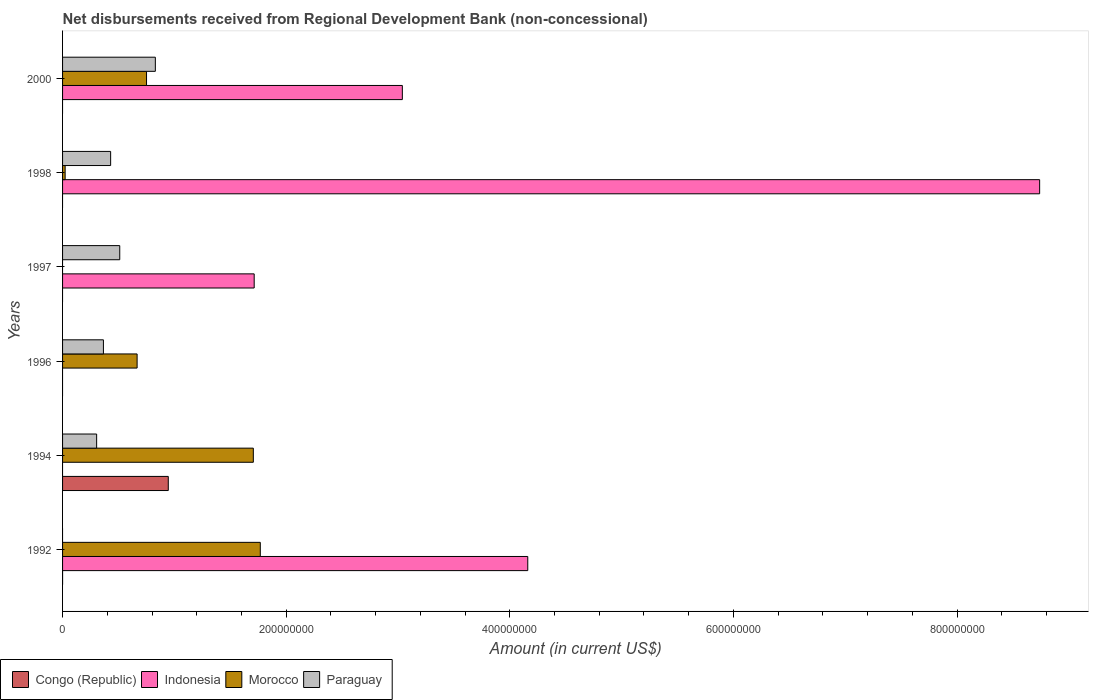Are the number of bars on each tick of the Y-axis equal?
Provide a succinct answer. No. How many bars are there on the 1st tick from the bottom?
Keep it short and to the point. 2. What is the label of the 1st group of bars from the top?
Keep it short and to the point. 2000. What is the amount of disbursements received from Regional Development Bank in Congo (Republic) in 2000?
Keep it short and to the point. 0. Across all years, what is the maximum amount of disbursements received from Regional Development Bank in Congo (Republic)?
Provide a succinct answer. 9.46e+07. What is the total amount of disbursements received from Regional Development Bank in Morocco in the graph?
Make the answer very short. 4.92e+08. What is the difference between the amount of disbursements received from Regional Development Bank in Indonesia in 1997 and that in 1998?
Your response must be concise. -7.03e+08. What is the difference between the amount of disbursements received from Regional Development Bank in Congo (Republic) in 1996 and the amount of disbursements received from Regional Development Bank in Paraguay in 2000?
Your answer should be very brief. -8.30e+07. What is the average amount of disbursements received from Regional Development Bank in Morocco per year?
Keep it short and to the point. 8.19e+07. In the year 1998, what is the difference between the amount of disbursements received from Regional Development Bank in Paraguay and amount of disbursements received from Regional Development Bank in Morocco?
Offer a very short reply. 4.07e+07. What is the ratio of the amount of disbursements received from Regional Development Bank in Morocco in 1992 to that in 1994?
Offer a terse response. 1.04. Is the amount of disbursements received from Regional Development Bank in Morocco in 1994 less than that in 1996?
Your answer should be very brief. No. What is the difference between the highest and the second highest amount of disbursements received from Regional Development Bank in Paraguay?
Keep it short and to the point. 3.18e+07. What is the difference between the highest and the lowest amount of disbursements received from Regional Development Bank in Paraguay?
Your answer should be compact. 8.30e+07. In how many years, is the amount of disbursements received from Regional Development Bank in Morocco greater than the average amount of disbursements received from Regional Development Bank in Morocco taken over all years?
Offer a terse response. 2. Is it the case that in every year, the sum of the amount of disbursements received from Regional Development Bank in Morocco and amount of disbursements received from Regional Development Bank in Congo (Republic) is greater than the sum of amount of disbursements received from Regional Development Bank in Indonesia and amount of disbursements received from Regional Development Bank in Paraguay?
Provide a short and direct response. No. How many bars are there?
Your answer should be compact. 15. Are all the bars in the graph horizontal?
Give a very brief answer. Yes. Are the values on the major ticks of X-axis written in scientific E-notation?
Provide a succinct answer. No. Does the graph contain any zero values?
Your answer should be compact. Yes. Does the graph contain grids?
Offer a terse response. No. Where does the legend appear in the graph?
Ensure brevity in your answer.  Bottom left. What is the title of the graph?
Make the answer very short. Net disbursements received from Regional Development Bank (non-concessional). Does "Kuwait" appear as one of the legend labels in the graph?
Keep it short and to the point. No. What is the label or title of the Y-axis?
Your response must be concise. Years. What is the Amount (in current US$) of Congo (Republic) in 1992?
Provide a succinct answer. 0. What is the Amount (in current US$) in Indonesia in 1992?
Keep it short and to the point. 4.16e+08. What is the Amount (in current US$) of Morocco in 1992?
Offer a very short reply. 1.77e+08. What is the Amount (in current US$) of Congo (Republic) in 1994?
Provide a succinct answer. 9.46e+07. What is the Amount (in current US$) of Indonesia in 1994?
Provide a short and direct response. 0. What is the Amount (in current US$) in Morocco in 1994?
Your answer should be compact. 1.71e+08. What is the Amount (in current US$) in Paraguay in 1994?
Ensure brevity in your answer.  3.05e+07. What is the Amount (in current US$) of Morocco in 1996?
Give a very brief answer. 6.67e+07. What is the Amount (in current US$) of Paraguay in 1996?
Provide a succinct answer. 3.65e+07. What is the Amount (in current US$) in Congo (Republic) in 1997?
Provide a short and direct response. 0. What is the Amount (in current US$) of Indonesia in 1997?
Make the answer very short. 1.71e+08. What is the Amount (in current US$) of Morocco in 1997?
Provide a short and direct response. 0. What is the Amount (in current US$) of Paraguay in 1997?
Your response must be concise. 5.11e+07. What is the Amount (in current US$) in Indonesia in 1998?
Your answer should be very brief. 8.74e+08. What is the Amount (in current US$) in Morocco in 1998?
Your response must be concise. 2.30e+06. What is the Amount (in current US$) in Paraguay in 1998?
Provide a succinct answer. 4.30e+07. What is the Amount (in current US$) of Congo (Republic) in 2000?
Provide a succinct answer. 0. What is the Amount (in current US$) of Indonesia in 2000?
Provide a short and direct response. 3.04e+08. What is the Amount (in current US$) in Morocco in 2000?
Give a very brief answer. 7.51e+07. What is the Amount (in current US$) of Paraguay in 2000?
Provide a short and direct response. 8.30e+07. Across all years, what is the maximum Amount (in current US$) in Congo (Republic)?
Offer a very short reply. 9.46e+07. Across all years, what is the maximum Amount (in current US$) in Indonesia?
Your response must be concise. 8.74e+08. Across all years, what is the maximum Amount (in current US$) of Morocco?
Your response must be concise. 1.77e+08. Across all years, what is the maximum Amount (in current US$) of Paraguay?
Provide a short and direct response. 8.30e+07. Across all years, what is the minimum Amount (in current US$) in Indonesia?
Your response must be concise. 0. Across all years, what is the minimum Amount (in current US$) in Paraguay?
Provide a short and direct response. 0. What is the total Amount (in current US$) in Congo (Republic) in the graph?
Give a very brief answer. 9.46e+07. What is the total Amount (in current US$) in Indonesia in the graph?
Provide a succinct answer. 1.77e+09. What is the total Amount (in current US$) in Morocco in the graph?
Provide a short and direct response. 4.92e+08. What is the total Amount (in current US$) in Paraguay in the graph?
Your answer should be very brief. 2.44e+08. What is the difference between the Amount (in current US$) in Morocco in 1992 and that in 1994?
Give a very brief answer. 6.23e+06. What is the difference between the Amount (in current US$) in Morocco in 1992 and that in 1996?
Provide a short and direct response. 1.10e+08. What is the difference between the Amount (in current US$) in Indonesia in 1992 and that in 1997?
Your answer should be compact. 2.45e+08. What is the difference between the Amount (in current US$) of Indonesia in 1992 and that in 1998?
Make the answer very short. -4.58e+08. What is the difference between the Amount (in current US$) of Morocco in 1992 and that in 1998?
Provide a succinct answer. 1.75e+08. What is the difference between the Amount (in current US$) in Indonesia in 1992 and that in 2000?
Provide a short and direct response. 1.12e+08. What is the difference between the Amount (in current US$) of Morocco in 1992 and that in 2000?
Your answer should be compact. 1.02e+08. What is the difference between the Amount (in current US$) in Morocco in 1994 and that in 1996?
Ensure brevity in your answer.  1.04e+08. What is the difference between the Amount (in current US$) in Paraguay in 1994 and that in 1996?
Your answer should be compact. -6.06e+06. What is the difference between the Amount (in current US$) in Paraguay in 1994 and that in 1997?
Keep it short and to the point. -2.07e+07. What is the difference between the Amount (in current US$) of Morocco in 1994 and that in 1998?
Offer a very short reply. 1.68e+08. What is the difference between the Amount (in current US$) in Paraguay in 1994 and that in 1998?
Make the answer very short. -1.25e+07. What is the difference between the Amount (in current US$) of Morocco in 1994 and that in 2000?
Keep it short and to the point. 9.55e+07. What is the difference between the Amount (in current US$) in Paraguay in 1994 and that in 2000?
Offer a terse response. -5.25e+07. What is the difference between the Amount (in current US$) of Paraguay in 1996 and that in 1997?
Your answer should be compact. -1.46e+07. What is the difference between the Amount (in current US$) of Morocco in 1996 and that in 1998?
Your response must be concise. 6.44e+07. What is the difference between the Amount (in current US$) of Paraguay in 1996 and that in 1998?
Make the answer very short. -6.46e+06. What is the difference between the Amount (in current US$) in Morocco in 1996 and that in 2000?
Keep it short and to the point. -8.43e+06. What is the difference between the Amount (in current US$) of Paraguay in 1996 and that in 2000?
Ensure brevity in your answer.  -4.64e+07. What is the difference between the Amount (in current US$) of Indonesia in 1997 and that in 1998?
Your answer should be very brief. -7.03e+08. What is the difference between the Amount (in current US$) in Paraguay in 1997 and that in 1998?
Offer a very short reply. 8.14e+06. What is the difference between the Amount (in current US$) in Indonesia in 1997 and that in 2000?
Ensure brevity in your answer.  -1.33e+08. What is the difference between the Amount (in current US$) of Paraguay in 1997 and that in 2000?
Give a very brief answer. -3.18e+07. What is the difference between the Amount (in current US$) in Indonesia in 1998 and that in 2000?
Provide a short and direct response. 5.70e+08. What is the difference between the Amount (in current US$) in Morocco in 1998 and that in 2000?
Offer a very short reply. -7.28e+07. What is the difference between the Amount (in current US$) in Paraguay in 1998 and that in 2000?
Give a very brief answer. -4.00e+07. What is the difference between the Amount (in current US$) in Indonesia in 1992 and the Amount (in current US$) in Morocco in 1994?
Provide a succinct answer. 2.45e+08. What is the difference between the Amount (in current US$) in Indonesia in 1992 and the Amount (in current US$) in Paraguay in 1994?
Provide a short and direct response. 3.86e+08. What is the difference between the Amount (in current US$) of Morocco in 1992 and the Amount (in current US$) of Paraguay in 1994?
Offer a very short reply. 1.46e+08. What is the difference between the Amount (in current US$) in Indonesia in 1992 and the Amount (in current US$) in Morocco in 1996?
Offer a very short reply. 3.49e+08. What is the difference between the Amount (in current US$) in Indonesia in 1992 and the Amount (in current US$) in Paraguay in 1996?
Your response must be concise. 3.80e+08. What is the difference between the Amount (in current US$) of Morocco in 1992 and the Amount (in current US$) of Paraguay in 1996?
Provide a short and direct response. 1.40e+08. What is the difference between the Amount (in current US$) of Indonesia in 1992 and the Amount (in current US$) of Paraguay in 1997?
Provide a succinct answer. 3.65e+08. What is the difference between the Amount (in current US$) of Morocco in 1992 and the Amount (in current US$) of Paraguay in 1997?
Provide a short and direct response. 1.26e+08. What is the difference between the Amount (in current US$) of Indonesia in 1992 and the Amount (in current US$) of Morocco in 1998?
Your response must be concise. 4.14e+08. What is the difference between the Amount (in current US$) of Indonesia in 1992 and the Amount (in current US$) of Paraguay in 1998?
Provide a short and direct response. 3.73e+08. What is the difference between the Amount (in current US$) in Morocco in 1992 and the Amount (in current US$) in Paraguay in 1998?
Offer a terse response. 1.34e+08. What is the difference between the Amount (in current US$) in Indonesia in 1992 and the Amount (in current US$) in Morocco in 2000?
Make the answer very short. 3.41e+08. What is the difference between the Amount (in current US$) of Indonesia in 1992 and the Amount (in current US$) of Paraguay in 2000?
Your response must be concise. 3.33e+08. What is the difference between the Amount (in current US$) in Morocco in 1992 and the Amount (in current US$) in Paraguay in 2000?
Your response must be concise. 9.39e+07. What is the difference between the Amount (in current US$) of Congo (Republic) in 1994 and the Amount (in current US$) of Morocco in 1996?
Your answer should be very brief. 2.79e+07. What is the difference between the Amount (in current US$) of Congo (Republic) in 1994 and the Amount (in current US$) of Paraguay in 1996?
Ensure brevity in your answer.  5.80e+07. What is the difference between the Amount (in current US$) of Morocco in 1994 and the Amount (in current US$) of Paraguay in 1996?
Provide a succinct answer. 1.34e+08. What is the difference between the Amount (in current US$) of Congo (Republic) in 1994 and the Amount (in current US$) of Indonesia in 1997?
Provide a succinct answer. -7.68e+07. What is the difference between the Amount (in current US$) in Congo (Republic) in 1994 and the Amount (in current US$) in Paraguay in 1997?
Make the answer very short. 4.34e+07. What is the difference between the Amount (in current US$) of Morocco in 1994 and the Amount (in current US$) of Paraguay in 1997?
Give a very brief answer. 1.19e+08. What is the difference between the Amount (in current US$) of Congo (Republic) in 1994 and the Amount (in current US$) of Indonesia in 1998?
Keep it short and to the point. -7.79e+08. What is the difference between the Amount (in current US$) in Congo (Republic) in 1994 and the Amount (in current US$) in Morocco in 1998?
Make the answer very short. 9.23e+07. What is the difference between the Amount (in current US$) of Congo (Republic) in 1994 and the Amount (in current US$) of Paraguay in 1998?
Make the answer very short. 5.16e+07. What is the difference between the Amount (in current US$) in Morocco in 1994 and the Amount (in current US$) in Paraguay in 1998?
Offer a very short reply. 1.28e+08. What is the difference between the Amount (in current US$) of Congo (Republic) in 1994 and the Amount (in current US$) of Indonesia in 2000?
Give a very brief answer. -2.09e+08. What is the difference between the Amount (in current US$) of Congo (Republic) in 1994 and the Amount (in current US$) of Morocco in 2000?
Offer a very short reply. 1.95e+07. What is the difference between the Amount (in current US$) in Congo (Republic) in 1994 and the Amount (in current US$) in Paraguay in 2000?
Offer a terse response. 1.16e+07. What is the difference between the Amount (in current US$) in Morocco in 1994 and the Amount (in current US$) in Paraguay in 2000?
Your response must be concise. 8.76e+07. What is the difference between the Amount (in current US$) of Morocco in 1996 and the Amount (in current US$) of Paraguay in 1997?
Ensure brevity in your answer.  1.55e+07. What is the difference between the Amount (in current US$) of Morocco in 1996 and the Amount (in current US$) of Paraguay in 1998?
Offer a terse response. 2.37e+07. What is the difference between the Amount (in current US$) in Morocco in 1996 and the Amount (in current US$) in Paraguay in 2000?
Make the answer very short. -1.63e+07. What is the difference between the Amount (in current US$) in Indonesia in 1997 and the Amount (in current US$) in Morocco in 1998?
Provide a short and direct response. 1.69e+08. What is the difference between the Amount (in current US$) of Indonesia in 1997 and the Amount (in current US$) of Paraguay in 1998?
Provide a short and direct response. 1.28e+08. What is the difference between the Amount (in current US$) in Indonesia in 1997 and the Amount (in current US$) in Morocco in 2000?
Make the answer very short. 9.63e+07. What is the difference between the Amount (in current US$) of Indonesia in 1997 and the Amount (in current US$) of Paraguay in 2000?
Ensure brevity in your answer.  8.84e+07. What is the difference between the Amount (in current US$) of Indonesia in 1998 and the Amount (in current US$) of Morocco in 2000?
Make the answer very short. 7.99e+08. What is the difference between the Amount (in current US$) of Indonesia in 1998 and the Amount (in current US$) of Paraguay in 2000?
Keep it short and to the point. 7.91e+08. What is the difference between the Amount (in current US$) of Morocco in 1998 and the Amount (in current US$) of Paraguay in 2000?
Provide a short and direct response. -8.07e+07. What is the average Amount (in current US$) of Congo (Republic) per year?
Give a very brief answer. 1.58e+07. What is the average Amount (in current US$) in Indonesia per year?
Offer a very short reply. 2.94e+08. What is the average Amount (in current US$) in Morocco per year?
Give a very brief answer. 8.19e+07. What is the average Amount (in current US$) in Paraguay per year?
Your response must be concise. 4.07e+07. In the year 1992, what is the difference between the Amount (in current US$) of Indonesia and Amount (in current US$) of Morocco?
Give a very brief answer. 2.39e+08. In the year 1994, what is the difference between the Amount (in current US$) of Congo (Republic) and Amount (in current US$) of Morocco?
Your answer should be very brief. -7.61e+07. In the year 1994, what is the difference between the Amount (in current US$) in Congo (Republic) and Amount (in current US$) in Paraguay?
Keep it short and to the point. 6.41e+07. In the year 1994, what is the difference between the Amount (in current US$) in Morocco and Amount (in current US$) in Paraguay?
Your response must be concise. 1.40e+08. In the year 1996, what is the difference between the Amount (in current US$) of Morocco and Amount (in current US$) of Paraguay?
Your answer should be very brief. 3.01e+07. In the year 1997, what is the difference between the Amount (in current US$) in Indonesia and Amount (in current US$) in Paraguay?
Provide a succinct answer. 1.20e+08. In the year 1998, what is the difference between the Amount (in current US$) in Indonesia and Amount (in current US$) in Morocco?
Offer a terse response. 8.72e+08. In the year 1998, what is the difference between the Amount (in current US$) of Indonesia and Amount (in current US$) of Paraguay?
Ensure brevity in your answer.  8.31e+08. In the year 1998, what is the difference between the Amount (in current US$) of Morocco and Amount (in current US$) of Paraguay?
Provide a succinct answer. -4.07e+07. In the year 2000, what is the difference between the Amount (in current US$) in Indonesia and Amount (in current US$) in Morocco?
Your response must be concise. 2.29e+08. In the year 2000, what is the difference between the Amount (in current US$) of Indonesia and Amount (in current US$) of Paraguay?
Give a very brief answer. 2.21e+08. In the year 2000, what is the difference between the Amount (in current US$) of Morocco and Amount (in current US$) of Paraguay?
Provide a short and direct response. -7.89e+06. What is the ratio of the Amount (in current US$) in Morocco in 1992 to that in 1994?
Give a very brief answer. 1.04. What is the ratio of the Amount (in current US$) of Morocco in 1992 to that in 1996?
Give a very brief answer. 2.65. What is the ratio of the Amount (in current US$) in Indonesia in 1992 to that in 1997?
Provide a short and direct response. 2.43. What is the ratio of the Amount (in current US$) of Indonesia in 1992 to that in 1998?
Your answer should be very brief. 0.48. What is the ratio of the Amount (in current US$) in Morocco in 1992 to that in 1998?
Make the answer very short. 77.03. What is the ratio of the Amount (in current US$) of Indonesia in 1992 to that in 2000?
Make the answer very short. 1.37. What is the ratio of the Amount (in current US$) of Morocco in 1992 to that in 2000?
Your answer should be compact. 2.35. What is the ratio of the Amount (in current US$) of Morocco in 1994 to that in 1996?
Keep it short and to the point. 2.56. What is the ratio of the Amount (in current US$) in Paraguay in 1994 to that in 1996?
Your response must be concise. 0.83. What is the ratio of the Amount (in current US$) in Paraguay in 1994 to that in 1997?
Ensure brevity in your answer.  0.6. What is the ratio of the Amount (in current US$) of Morocco in 1994 to that in 1998?
Your answer should be very brief. 74.31. What is the ratio of the Amount (in current US$) in Paraguay in 1994 to that in 1998?
Give a very brief answer. 0.71. What is the ratio of the Amount (in current US$) of Morocco in 1994 to that in 2000?
Give a very brief answer. 2.27. What is the ratio of the Amount (in current US$) in Paraguay in 1994 to that in 2000?
Offer a very short reply. 0.37. What is the ratio of the Amount (in current US$) in Paraguay in 1996 to that in 1997?
Offer a terse response. 0.71. What is the ratio of the Amount (in current US$) in Morocco in 1996 to that in 1998?
Give a very brief answer. 29.04. What is the ratio of the Amount (in current US$) in Paraguay in 1996 to that in 1998?
Ensure brevity in your answer.  0.85. What is the ratio of the Amount (in current US$) of Morocco in 1996 to that in 2000?
Make the answer very short. 0.89. What is the ratio of the Amount (in current US$) of Paraguay in 1996 to that in 2000?
Offer a very short reply. 0.44. What is the ratio of the Amount (in current US$) of Indonesia in 1997 to that in 1998?
Ensure brevity in your answer.  0.2. What is the ratio of the Amount (in current US$) of Paraguay in 1997 to that in 1998?
Give a very brief answer. 1.19. What is the ratio of the Amount (in current US$) of Indonesia in 1997 to that in 2000?
Make the answer very short. 0.56. What is the ratio of the Amount (in current US$) of Paraguay in 1997 to that in 2000?
Your answer should be very brief. 0.62. What is the ratio of the Amount (in current US$) in Indonesia in 1998 to that in 2000?
Make the answer very short. 2.88. What is the ratio of the Amount (in current US$) of Morocco in 1998 to that in 2000?
Make the answer very short. 0.03. What is the ratio of the Amount (in current US$) of Paraguay in 1998 to that in 2000?
Provide a short and direct response. 0.52. What is the difference between the highest and the second highest Amount (in current US$) in Indonesia?
Your answer should be very brief. 4.58e+08. What is the difference between the highest and the second highest Amount (in current US$) in Morocco?
Provide a short and direct response. 6.23e+06. What is the difference between the highest and the second highest Amount (in current US$) in Paraguay?
Make the answer very short. 3.18e+07. What is the difference between the highest and the lowest Amount (in current US$) of Congo (Republic)?
Your answer should be very brief. 9.46e+07. What is the difference between the highest and the lowest Amount (in current US$) of Indonesia?
Offer a terse response. 8.74e+08. What is the difference between the highest and the lowest Amount (in current US$) in Morocco?
Provide a succinct answer. 1.77e+08. What is the difference between the highest and the lowest Amount (in current US$) in Paraguay?
Ensure brevity in your answer.  8.30e+07. 